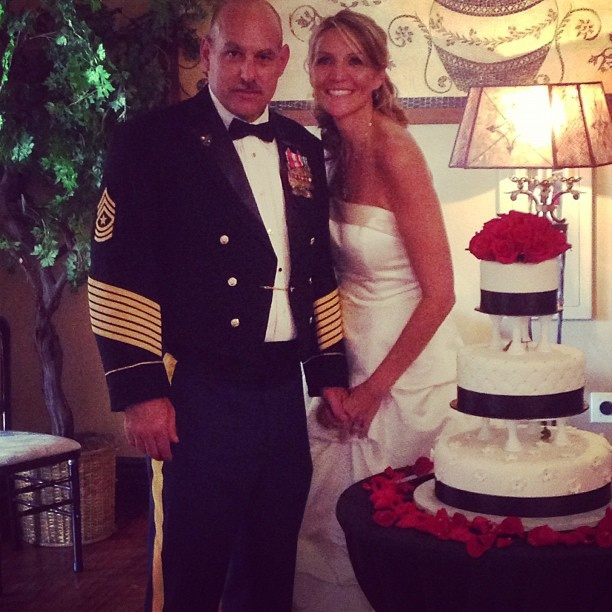Describe the objects in this image and their specific colors. I can see people in black, maroon, and brown tones, people in black, brown, darkgray, maroon, and tan tones, potted plant in black, purple, and gray tones, cake in black and tan tones, and dining table in black, maroon, brown, and gray tones in this image. 